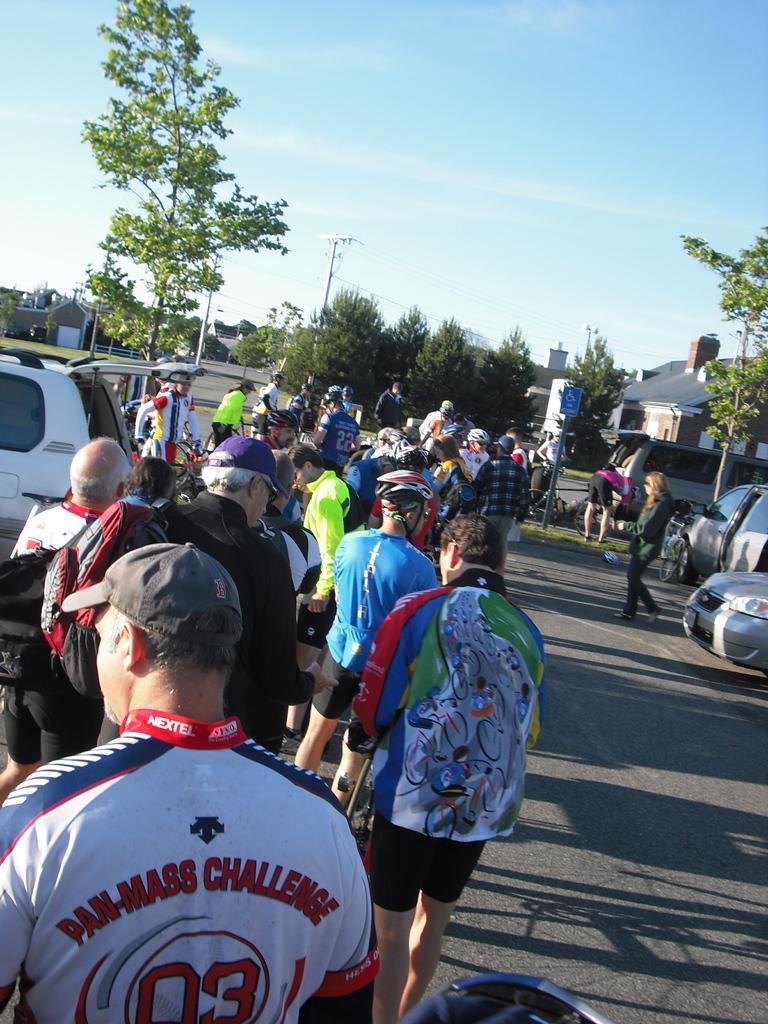Describe this image in one or two sentences. This is a picture where we have a group of people standing on the street and there are some trees and cars around them. 